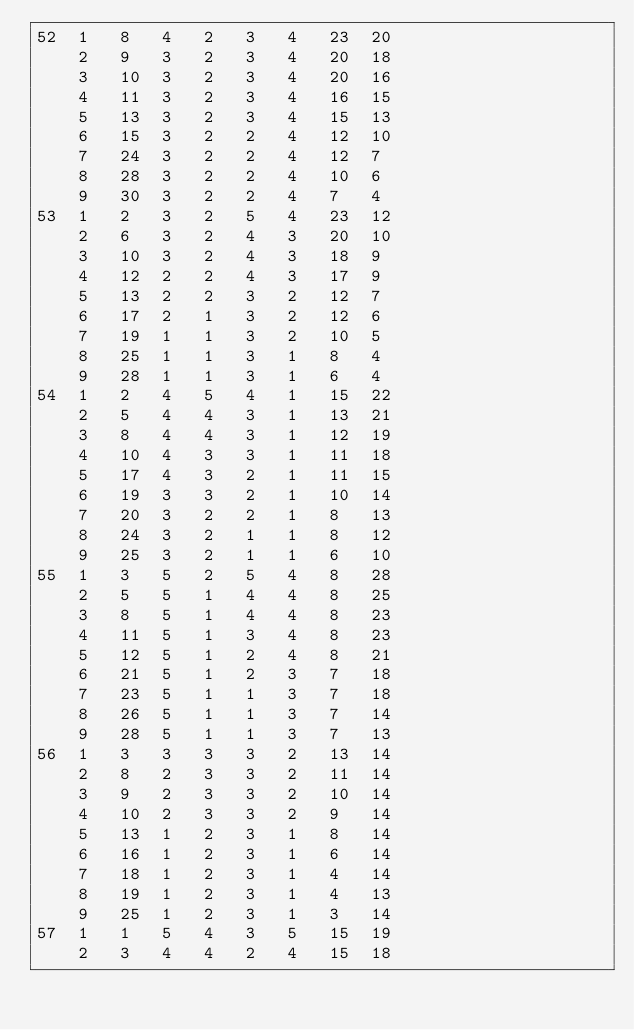<code> <loc_0><loc_0><loc_500><loc_500><_ObjectiveC_>52	1	8	4	2	3	4	23	20	
	2	9	3	2	3	4	20	18	
	3	10	3	2	3	4	20	16	
	4	11	3	2	3	4	16	15	
	5	13	3	2	3	4	15	13	
	6	15	3	2	2	4	12	10	
	7	24	3	2	2	4	12	7	
	8	28	3	2	2	4	10	6	
	9	30	3	2	2	4	7	4	
53	1	2	3	2	5	4	23	12	
	2	6	3	2	4	3	20	10	
	3	10	3	2	4	3	18	9	
	4	12	2	2	4	3	17	9	
	5	13	2	2	3	2	12	7	
	6	17	2	1	3	2	12	6	
	7	19	1	1	3	2	10	5	
	8	25	1	1	3	1	8	4	
	9	28	1	1	3	1	6	4	
54	1	2	4	5	4	1	15	22	
	2	5	4	4	3	1	13	21	
	3	8	4	4	3	1	12	19	
	4	10	4	3	3	1	11	18	
	5	17	4	3	2	1	11	15	
	6	19	3	3	2	1	10	14	
	7	20	3	2	2	1	8	13	
	8	24	3	2	1	1	8	12	
	9	25	3	2	1	1	6	10	
55	1	3	5	2	5	4	8	28	
	2	5	5	1	4	4	8	25	
	3	8	5	1	4	4	8	23	
	4	11	5	1	3	4	8	23	
	5	12	5	1	2	4	8	21	
	6	21	5	1	2	3	7	18	
	7	23	5	1	1	3	7	18	
	8	26	5	1	1	3	7	14	
	9	28	5	1	1	3	7	13	
56	1	3	3	3	3	2	13	14	
	2	8	2	3	3	2	11	14	
	3	9	2	3	3	2	10	14	
	4	10	2	3	3	2	9	14	
	5	13	1	2	3	1	8	14	
	6	16	1	2	3	1	6	14	
	7	18	1	2	3	1	4	14	
	8	19	1	2	3	1	4	13	
	9	25	1	2	3	1	3	14	
57	1	1	5	4	3	5	15	19	
	2	3	4	4	2	4	15	18	</code> 